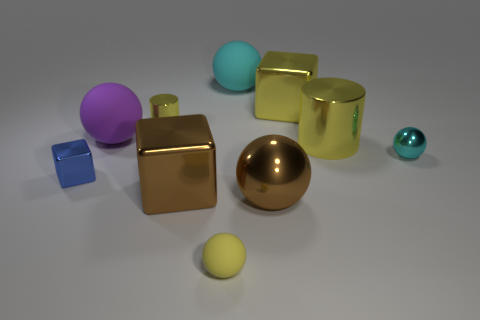Are there the same number of small blue shiny cubes behind the tiny yellow cylinder and red metal cylinders?
Offer a terse response. Yes. How many tiny blue blocks are the same material as the purple sphere?
Give a very brief answer. 0. The small block that is the same material as the tiny cyan sphere is what color?
Provide a short and direct response. Blue. Do the yellow sphere and the metal cylinder in front of the large purple sphere have the same size?
Your answer should be compact. No. What is the shape of the large purple thing?
Offer a very short reply. Sphere. What number of matte objects are the same color as the small cylinder?
Your answer should be compact. 1. There is another big rubber thing that is the same shape as the big cyan matte thing; what color is it?
Keep it short and to the point. Purple. How many small metal spheres are on the right side of the yellow object that is in front of the tiny cyan sphere?
Your answer should be very brief. 1. How many cubes are either tiny yellow rubber things or big purple matte things?
Keep it short and to the point. 0. Are there any large rubber things?
Provide a short and direct response. Yes. 